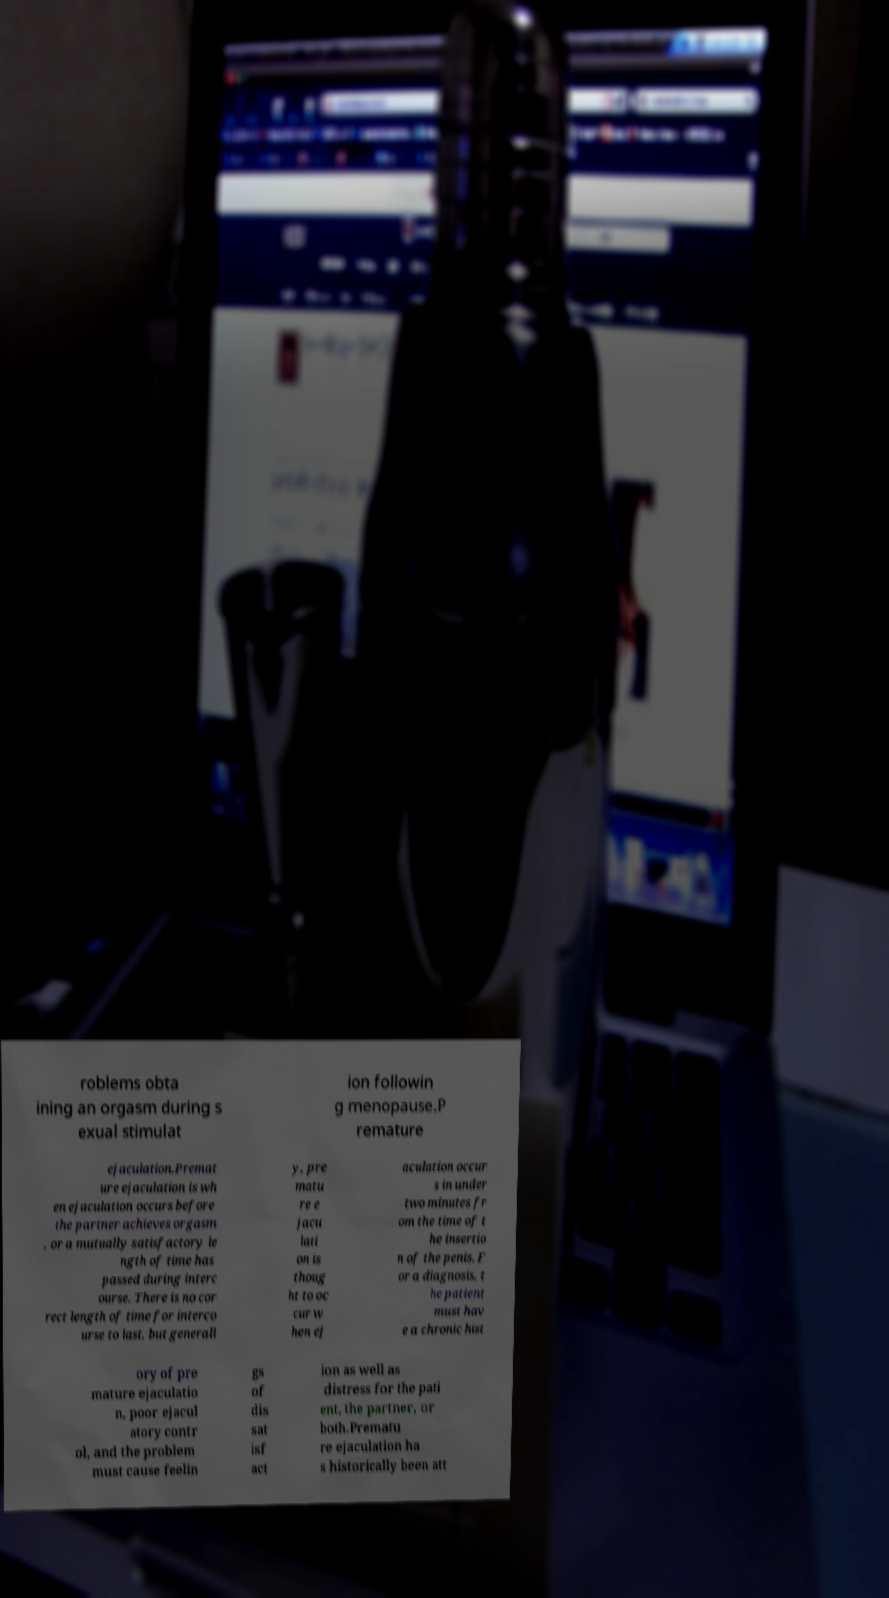Could you extract and type out the text from this image? roblems obta ining an orgasm during s exual stimulat ion followin g menopause.P remature ejaculation.Premat ure ejaculation is wh en ejaculation occurs before the partner achieves orgasm , or a mutually satisfactory le ngth of time has passed during interc ourse. There is no cor rect length of time for interco urse to last, but generall y, pre matu re e jacu lati on is thoug ht to oc cur w hen ej aculation occur s in under two minutes fr om the time of t he insertio n of the penis. F or a diagnosis, t he patient must hav e a chronic hist ory of pre mature ejaculatio n, poor ejacul atory contr ol, and the problem must cause feelin gs of dis sat isf act ion as well as distress for the pati ent, the partner, or both.Prematu re ejaculation ha s historically been att 